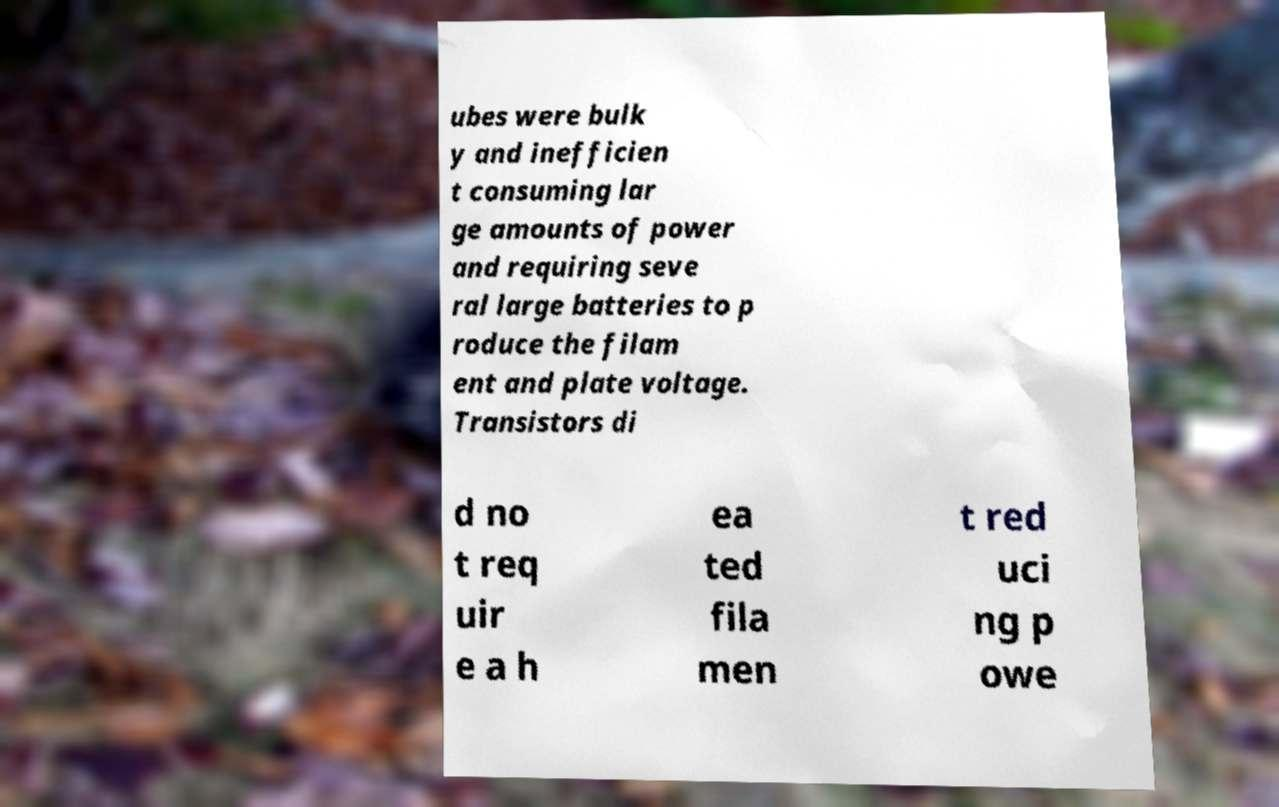For documentation purposes, I need the text within this image transcribed. Could you provide that? ubes were bulk y and inefficien t consuming lar ge amounts of power and requiring seve ral large batteries to p roduce the filam ent and plate voltage. Transistors di d no t req uir e a h ea ted fila men t red uci ng p owe 